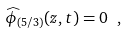<formula> <loc_0><loc_0><loc_500><loc_500>\widehat { \phi } _ { ( 5 / 3 ) } ( z , t ) = 0 \ ,</formula> 